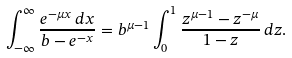<formula> <loc_0><loc_0><loc_500><loc_500>\int _ { - \infty } ^ { \infty } \frac { e ^ { - \mu x } \, d x } { b - e ^ { - x } } = b ^ { \mu - 1 } \int _ { 0 } ^ { 1 } \frac { z ^ { \mu - 1 } - z ^ { - \mu } } { 1 - z } \, d z .</formula> 